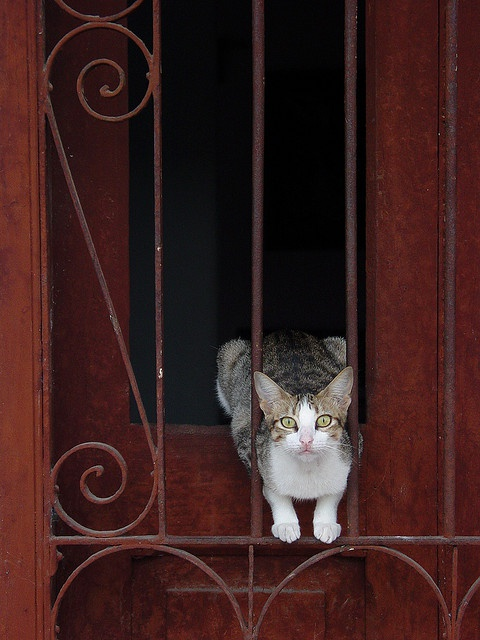Describe the objects in this image and their specific colors. I can see a cat in maroon, darkgray, black, lightgray, and gray tones in this image. 